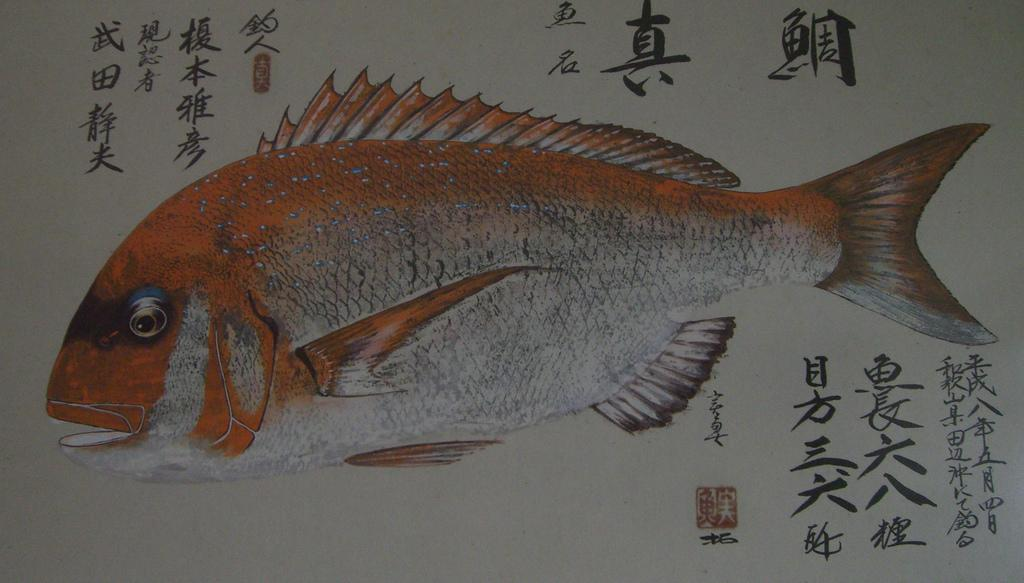What is the main subject of the image? There is a picture in the image. What can be seen in the picture? The picture contains fish. Is there any text present in the image? Yes, there is text written on a paper in the picture. What type of pin is holding the paper with text in the image? There is no pin present in the image; the text is written on a paper within the picture of fish. Can you describe the woman in the image? There is no woman present in the image; it contains a picture of fish with text written on a paper. 